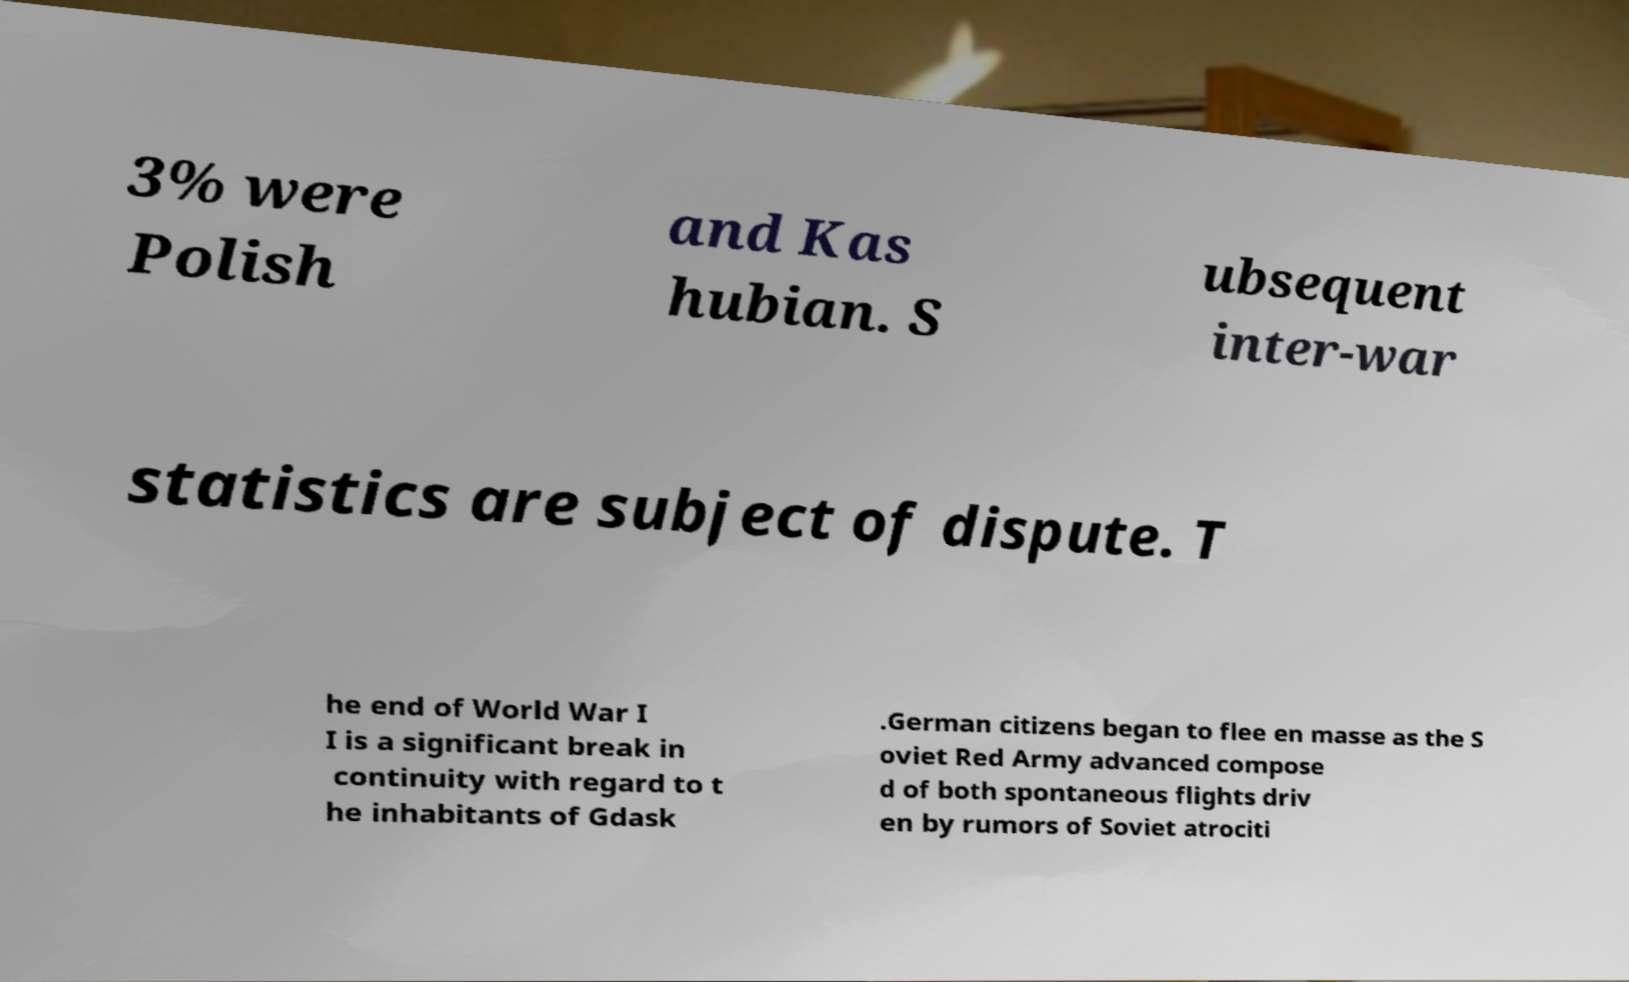There's text embedded in this image that I need extracted. Can you transcribe it verbatim? 3% were Polish and Kas hubian. S ubsequent inter-war statistics are subject of dispute. T he end of World War I I is a significant break in continuity with regard to t he inhabitants of Gdask .German citizens began to flee en masse as the S oviet Red Army advanced compose d of both spontaneous flights driv en by rumors of Soviet atrociti 